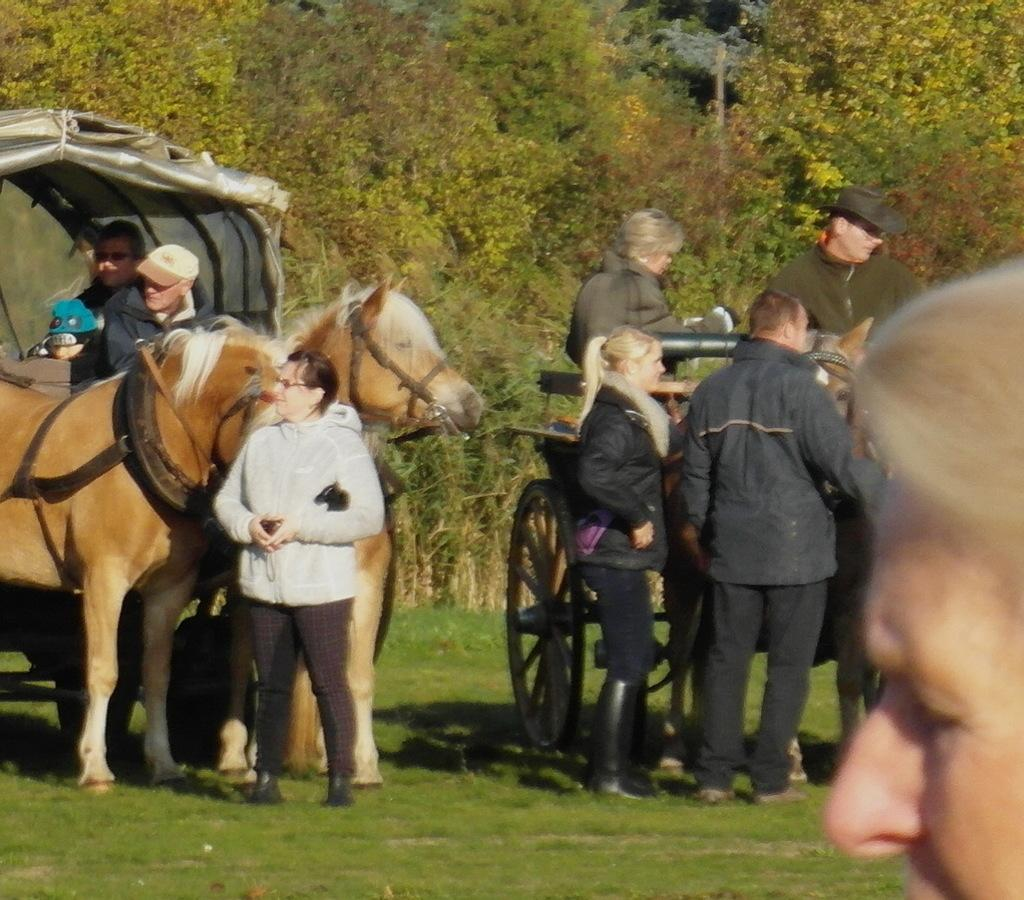What are the persons in the image doing? The persons in the image are sitting in a cart. How many horses are pulling the cart? There are 3 horses pulling the cart. What are the people standing on in the image? The people standing on the grass. What can be seen in the background of the image? Trees are visible in the background of the image. What time of day is it in the image, as indicated by the hour on a clock? There is no clock visible in the image, so we cannot determine the time of day based on an hour. 